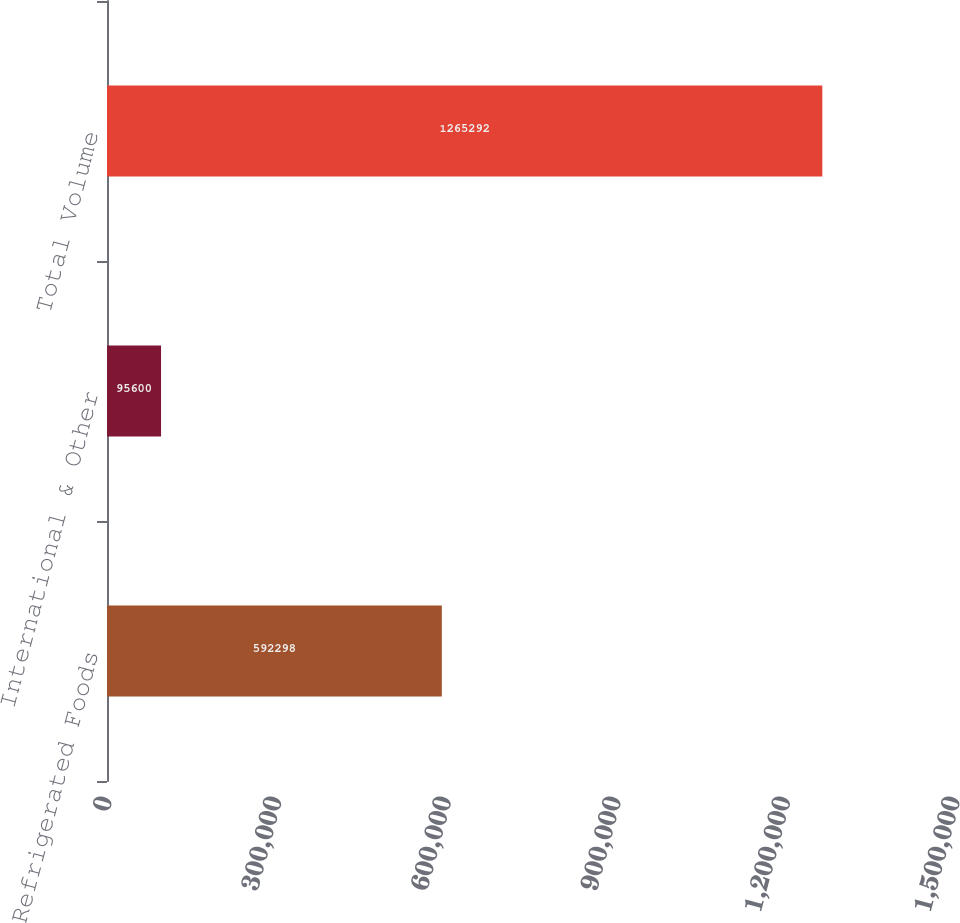<chart> <loc_0><loc_0><loc_500><loc_500><bar_chart><fcel>Refrigerated Foods<fcel>International & Other<fcel>Total Volume<nl><fcel>592298<fcel>95600<fcel>1.26529e+06<nl></chart> 